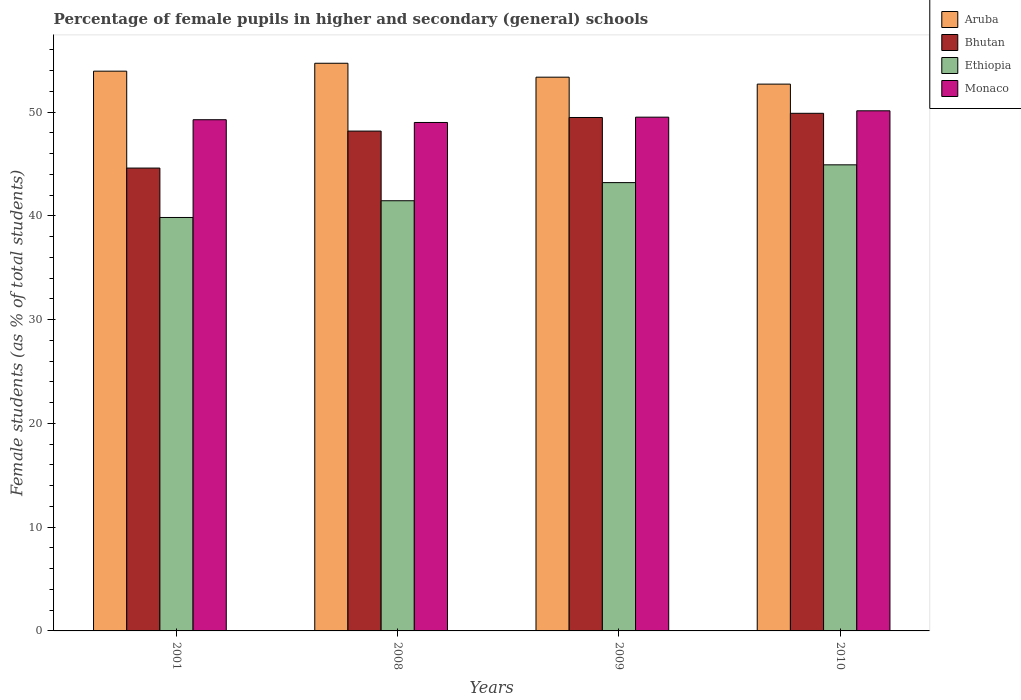How many bars are there on the 3rd tick from the left?
Give a very brief answer. 4. How many bars are there on the 4th tick from the right?
Keep it short and to the point. 4. What is the percentage of female pupils in higher and secondary schools in Monaco in 2010?
Your answer should be very brief. 50.12. Across all years, what is the maximum percentage of female pupils in higher and secondary schools in Aruba?
Your answer should be compact. 54.7. Across all years, what is the minimum percentage of female pupils in higher and secondary schools in Ethiopia?
Give a very brief answer. 39.84. What is the total percentage of female pupils in higher and secondary schools in Bhutan in the graph?
Ensure brevity in your answer.  192.13. What is the difference between the percentage of female pupils in higher and secondary schools in Aruba in 2001 and that in 2009?
Give a very brief answer. 0.58. What is the difference between the percentage of female pupils in higher and secondary schools in Monaco in 2001 and the percentage of female pupils in higher and secondary schools in Aruba in 2009?
Your response must be concise. -4.1. What is the average percentage of female pupils in higher and secondary schools in Ethiopia per year?
Make the answer very short. 42.35. In the year 2008, what is the difference between the percentage of female pupils in higher and secondary schools in Aruba and percentage of female pupils in higher and secondary schools in Monaco?
Provide a short and direct response. 5.71. In how many years, is the percentage of female pupils in higher and secondary schools in Ethiopia greater than 16 %?
Your answer should be very brief. 4. What is the ratio of the percentage of female pupils in higher and secondary schools in Aruba in 2001 to that in 2010?
Make the answer very short. 1.02. Is the percentage of female pupils in higher and secondary schools in Aruba in 2009 less than that in 2010?
Make the answer very short. No. Is the difference between the percentage of female pupils in higher and secondary schools in Aruba in 2001 and 2008 greater than the difference between the percentage of female pupils in higher and secondary schools in Monaco in 2001 and 2008?
Make the answer very short. No. What is the difference between the highest and the second highest percentage of female pupils in higher and secondary schools in Ethiopia?
Offer a very short reply. 1.71. What is the difference between the highest and the lowest percentage of female pupils in higher and secondary schools in Aruba?
Give a very brief answer. 2.01. Is the sum of the percentage of female pupils in higher and secondary schools in Ethiopia in 2001 and 2009 greater than the maximum percentage of female pupils in higher and secondary schools in Aruba across all years?
Your response must be concise. Yes. What does the 2nd bar from the left in 2010 represents?
Offer a very short reply. Bhutan. What does the 1st bar from the right in 2008 represents?
Keep it short and to the point. Monaco. Is it the case that in every year, the sum of the percentage of female pupils in higher and secondary schools in Ethiopia and percentage of female pupils in higher and secondary schools in Bhutan is greater than the percentage of female pupils in higher and secondary schools in Monaco?
Ensure brevity in your answer.  Yes. How many bars are there?
Offer a very short reply. 16. Are all the bars in the graph horizontal?
Your answer should be compact. No. How many years are there in the graph?
Your response must be concise. 4. Does the graph contain any zero values?
Your answer should be compact. No. How many legend labels are there?
Provide a short and direct response. 4. What is the title of the graph?
Provide a succinct answer. Percentage of female pupils in higher and secondary (general) schools. Does "Georgia" appear as one of the legend labels in the graph?
Offer a very short reply. No. What is the label or title of the X-axis?
Give a very brief answer. Years. What is the label or title of the Y-axis?
Ensure brevity in your answer.  Female students (as % of total students). What is the Female students (as % of total students) of Aruba in 2001?
Offer a terse response. 53.94. What is the Female students (as % of total students) in Bhutan in 2001?
Ensure brevity in your answer.  44.6. What is the Female students (as % of total students) of Ethiopia in 2001?
Offer a terse response. 39.84. What is the Female students (as % of total students) in Monaco in 2001?
Keep it short and to the point. 49.26. What is the Female students (as % of total students) of Aruba in 2008?
Provide a short and direct response. 54.7. What is the Female students (as % of total students) in Bhutan in 2008?
Your answer should be very brief. 48.17. What is the Female students (as % of total students) of Ethiopia in 2008?
Your answer should be compact. 41.45. What is the Female students (as % of total students) in Monaco in 2008?
Keep it short and to the point. 49. What is the Female students (as % of total students) of Aruba in 2009?
Provide a short and direct response. 53.36. What is the Female students (as % of total students) of Bhutan in 2009?
Your answer should be very brief. 49.48. What is the Female students (as % of total students) in Ethiopia in 2009?
Your answer should be compact. 43.2. What is the Female students (as % of total students) of Monaco in 2009?
Ensure brevity in your answer.  49.51. What is the Female students (as % of total students) in Aruba in 2010?
Provide a succinct answer. 52.69. What is the Female students (as % of total students) of Bhutan in 2010?
Your answer should be very brief. 49.88. What is the Female students (as % of total students) of Ethiopia in 2010?
Ensure brevity in your answer.  44.92. What is the Female students (as % of total students) in Monaco in 2010?
Your response must be concise. 50.12. Across all years, what is the maximum Female students (as % of total students) in Aruba?
Provide a short and direct response. 54.7. Across all years, what is the maximum Female students (as % of total students) in Bhutan?
Make the answer very short. 49.88. Across all years, what is the maximum Female students (as % of total students) in Ethiopia?
Offer a terse response. 44.92. Across all years, what is the maximum Female students (as % of total students) of Monaco?
Provide a succinct answer. 50.12. Across all years, what is the minimum Female students (as % of total students) of Aruba?
Provide a succinct answer. 52.69. Across all years, what is the minimum Female students (as % of total students) in Bhutan?
Ensure brevity in your answer.  44.6. Across all years, what is the minimum Female students (as % of total students) of Ethiopia?
Offer a very short reply. 39.84. Across all years, what is the minimum Female students (as % of total students) in Monaco?
Your answer should be very brief. 49. What is the total Female students (as % of total students) in Aruba in the graph?
Ensure brevity in your answer.  214.7. What is the total Female students (as % of total students) of Bhutan in the graph?
Offer a very short reply. 192.13. What is the total Female students (as % of total students) in Ethiopia in the graph?
Provide a short and direct response. 169.41. What is the total Female students (as % of total students) in Monaco in the graph?
Provide a succinct answer. 197.89. What is the difference between the Female students (as % of total students) in Aruba in 2001 and that in 2008?
Your response must be concise. -0.76. What is the difference between the Female students (as % of total students) in Bhutan in 2001 and that in 2008?
Ensure brevity in your answer.  -3.56. What is the difference between the Female students (as % of total students) of Ethiopia in 2001 and that in 2008?
Provide a short and direct response. -1.61. What is the difference between the Female students (as % of total students) in Monaco in 2001 and that in 2008?
Offer a terse response. 0.26. What is the difference between the Female students (as % of total students) in Aruba in 2001 and that in 2009?
Offer a terse response. 0.58. What is the difference between the Female students (as % of total students) in Bhutan in 2001 and that in 2009?
Your response must be concise. -4.87. What is the difference between the Female students (as % of total students) in Ethiopia in 2001 and that in 2009?
Offer a terse response. -3.36. What is the difference between the Female students (as % of total students) in Monaco in 2001 and that in 2009?
Provide a succinct answer. -0.25. What is the difference between the Female students (as % of total students) in Aruba in 2001 and that in 2010?
Make the answer very short. 1.25. What is the difference between the Female students (as % of total students) of Bhutan in 2001 and that in 2010?
Your answer should be compact. -5.28. What is the difference between the Female students (as % of total students) of Ethiopia in 2001 and that in 2010?
Your answer should be compact. -5.07. What is the difference between the Female students (as % of total students) in Monaco in 2001 and that in 2010?
Provide a short and direct response. -0.86. What is the difference between the Female students (as % of total students) in Aruba in 2008 and that in 2009?
Provide a succinct answer. 1.34. What is the difference between the Female students (as % of total students) of Bhutan in 2008 and that in 2009?
Give a very brief answer. -1.31. What is the difference between the Female students (as % of total students) of Ethiopia in 2008 and that in 2009?
Your answer should be compact. -1.75. What is the difference between the Female students (as % of total students) in Monaco in 2008 and that in 2009?
Provide a short and direct response. -0.51. What is the difference between the Female students (as % of total students) in Aruba in 2008 and that in 2010?
Your response must be concise. 2.01. What is the difference between the Female students (as % of total students) of Bhutan in 2008 and that in 2010?
Ensure brevity in your answer.  -1.71. What is the difference between the Female students (as % of total students) in Ethiopia in 2008 and that in 2010?
Offer a very short reply. -3.46. What is the difference between the Female students (as % of total students) in Monaco in 2008 and that in 2010?
Keep it short and to the point. -1.12. What is the difference between the Female students (as % of total students) in Aruba in 2009 and that in 2010?
Provide a succinct answer. 0.67. What is the difference between the Female students (as % of total students) in Bhutan in 2009 and that in 2010?
Offer a very short reply. -0.4. What is the difference between the Female students (as % of total students) of Ethiopia in 2009 and that in 2010?
Keep it short and to the point. -1.71. What is the difference between the Female students (as % of total students) in Monaco in 2009 and that in 2010?
Your answer should be compact. -0.61. What is the difference between the Female students (as % of total students) in Aruba in 2001 and the Female students (as % of total students) in Bhutan in 2008?
Ensure brevity in your answer.  5.78. What is the difference between the Female students (as % of total students) of Aruba in 2001 and the Female students (as % of total students) of Ethiopia in 2008?
Your answer should be compact. 12.49. What is the difference between the Female students (as % of total students) in Aruba in 2001 and the Female students (as % of total students) in Monaco in 2008?
Offer a terse response. 4.95. What is the difference between the Female students (as % of total students) in Bhutan in 2001 and the Female students (as % of total students) in Ethiopia in 2008?
Provide a short and direct response. 3.15. What is the difference between the Female students (as % of total students) of Bhutan in 2001 and the Female students (as % of total students) of Monaco in 2008?
Make the answer very short. -4.39. What is the difference between the Female students (as % of total students) in Ethiopia in 2001 and the Female students (as % of total students) in Monaco in 2008?
Your answer should be very brief. -9.16. What is the difference between the Female students (as % of total students) in Aruba in 2001 and the Female students (as % of total students) in Bhutan in 2009?
Provide a short and direct response. 4.47. What is the difference between the Female students (as % of total students) of Aruba in 2001 and the Female students (as % of total students) of Ethiopia in 2009?
Make the answer very short. 10.74. What is the difference between the Female students (as % of total students) of Aruba in 2001 and the Female students (as % of total students) of Monaco in 2009?
Your response must be concise. 4.43. What is the difference between the Female students (as % of total students) in Bhutan in 2001 and the Female students (as % of total students) in Ethiopia in 2009?
Your answer should be very brief. 1.4. What is the difference between the Female students (as % of total students) of Bhutan in 2001 and the Female students (as % of total students) of Monaco in 2009?
Offer a very short reply. -4.91. What is the difference between the Female students (as % of total students) in Ethiopia in 2001 and the Female students (as % of total students) in Monaco in 2009?
Your answer should be very brief. -9.67. What is the difference between the Female students (as % of total students) of Aruba in 2001 and the Female students (as % of total students) of Bhutan in 2010?
Keep it short and to the point. 4.06. What is the difference between the Female students (as % of total students) in Aruba in 2001 and the Female students (as % of total students) in Ethiopia in 2010?
Make the answer very short. 9.03. What is the difference between the Female students (as % of total students) of Aruba in 2001 and the Female students (as % of total students) of Monaco in 2010?
Ensure brevity in your answer.  3.82. What is the difference between the Female students (as % of total students) of Bhutan in 2001 and the Female students (as % of total students) of Ethiopia in 2010?
Your answer should be very brief. -0.31. What is the difference between the Female students (as % of total students) in Bhutan in 2001 and the Female students (as % of total students) in Monaco in 2010?
Offer a terse response. -5.52. What is the difference between the Female students (as % of total students) in Ethiopia in 2001 and the Female students (as % of total students) in Monaco in 2010?
Provide a succinct answer. -10.28. What is the difference between the Female students (as % of total students) of Aruba in 2008 and the Female students (as % of total students) of Bhutan in 2009?
Provide a short and direct response. 5.23. What is the difference between the Female students (as % of total students) of Aruba in 2008 and the Female students (as % of total students) of Ethiopia in 2009?
Give a very brief answer. 11.5. What is the difference between the Female students (as % of total students) in Aruba in 2008 and the Female students (as % of total students) in Monaco in 2009?
Your response must be concise. 5.2. What is the difference between the Female students (as % of total students) of Bhutan in 2008 and the Female students (as % of total students) of Ethiopia in 2009?
Your answer should be very brief. 4.97. What is the difference between the Female students (as % of total students) of Bhutan in 2008 and the Female students (as % of total students) of Monaco in 2009?
Your response must be concise. -1.34. What is the difference between the Female students (as % of total students) in Ethiopia in 2008 and the Female students (as % of total students) in Monaco in 2009?
Your answer should be compact. -8.05. What is the difference between the Female students (as % of total students) in Aruba in 2008 and the Female students (as % of total students) in Bhutan in 2010?
Ensure brevity in your answer.  4.82. What is the difference between the Female students (as % of total students) in Aruba in 2008 and the Female students (as % of total students) in Ethiopia in 2010?
Offer a terse response. 9.79. What is the difference between the Female students (as % of total students) in Aruba in 2008 and the Female students (as % of total students) in Monaco in 2010?
Your response must be concise. 4.58. What is the difference between the Female students (as % of total students) in Bhutan in 2008 and the Female students (as % of total students) in Ethiopia in 2010?
Offer a terse response. 3.25. What is the difference between the Female students (as % of total students) in Bhutan in 2008 and the Female students (as % of total students) in Monaco in 2010?
Your answer should be compact. -1.96. What is the difference between the Female students (as % of total students) in Ethiopia in 2008 and the Female students (as % of total students) in Monaco in 2010?
Provide a succinct answer. -8.67. What is the difference between the Female students (as % of total students) in Aruba in 2009 and the Female students (as % of total students) in Bhutan in 2010?
Your answer should be compact. 3.48. What is the difference between the Female students (as % of total students) of Aruba in 2009 and the Female students (as % of total students) of Ethiopia in 2010?
Offer a terse response. 8.45. What is the difference between the Female students (as % of total students) of Aruba in 2009 and the Female students (as % of total students) of Monaco in 2010?
Make the answer very short. 3.24. What is the difference between the Female students (as % of total students) in Bhutan in 2009 and the Female students (as % of total students) in Ethiopia in 2010?
Provide a short and direct response. 4.56. What is the difference between the Female students (as % of total students) of Bhutan in 2009 and the Female students (as % of total students) of Monaco in 2010?
Your answer should be compact. -0.64. What is the difference between the Female students (as % of total students) of Ethiopia in 2009 and the Female students (as % of total students) of Monaco in 2010?
Your answer should be very brief. -6.92. What is the average Female students (as % of total students) of Aruba per year?
Provide a succinct answer. 53.68. What is the average Female students (as % of total students) of Bhutan per year?
Ensure brevity in your answer.  48.03. What is the average Female students (as % of total students) of Ethiopia per year?
Offer a very short reply. 42.35. What is the average Female students (as % of total students) of Monaco per year?
Provide a succinct answer. 49.47. In the year 2001, what is the difference between the Female students (as % of total students) in Aruba and Female students (as % of total students) in Bhutan?
Give a very brief answer. 9.34. In the year 2001, what is the difference between the Female students (as % of total students) of Aruba and Female students (as % of total students) of Ethiopia?
Offer a very short reply. 14.1. In the year 2001, what is the difference between the Female students (as % of total students) of Aruba and Female students (as % of total students) of Monaco?
Your answer should be very brief. 4.68. In the year 2001, what is the difference between the Female students (as % of total students) of Bhutan and Female students (as % of total students) of Ethiopia?
Your answer should be very brief. 4.76. In the year 2001, what is the difference between the Female students (as % of total students) in Bhutan and Female students (as % of total students) in Monaco?
Keep it short and to the point. -4.66. In the year 2001, what is the difference between the Female students (as % of total students) in Ethiopia and Female students (as % of total students) in Monaco?
Give a very brief answer. -9.42. In the year 2008, what is the difference between the Female students (as % of total students) of Aruba and Female students (as % of total students) of Bhutan?
Offer a terse response. 6.54. In the year 2008, what is the difference between the Female students (as % of total students) in Aruba and Female students (as % of total students) in Ethiopia?
Offer a terse response. 13.25. In the year 2008, what is the difference between the Female students (as % of total students) of Aruba and Female students (as % of total students) of Monaco?
Offer a terse response. 5.71. In the year 2008, what is the difference between the Female students (as % of total students) in Bhutan and Female students (as % of total students) in Ethiopia?
Ensure brevity in your answer.  6.71. In the year 2008, what is the difference between the Female students (as % of total students) in Bhutan and Female students (as % of total students) in Monaco?
Give a very brief answer. -0.83. In the year 2008, what is the difference between the Female students (as % of total students) of Ethiopia and Female students (as % of total students) of Monaco?
Offer a very short reply. -7.54. In the year 2009, what is the difference between the Female students (as % of total students) of Aruba and Female students (as % of total students) of Bhutan?
Your response must be concise. 3.88. In the year 2009, what is the difference between the Female students (as % of total students) of Aruba and Female students (as % of total students) of Ethiopia?
Offer a terse response. 10.16. In the year 2009, what is the difference between the Female students (as % of total students) of Aruba and Female students (as % of total students) of Monaco?
Your answer should be compact. 3.85. In the year 2009, what is the difference between the Female students (as % of total students) in Bhutan and Female students (as % of total students) in Ethiopia?
Offer a very short reply. 6.28. In the year 2009, what is the difference between the Female students (as % of total students) of Bhutan and Female students (as % of total students) of Monaco?
Your answer should be very brief. -0.03. In the year 2009, what is the difference between the Female students (as % of total students) of Ethiopia and Female students (as % of total students) of Monaco?
Your answer should be compact. -6.31. In the year 2010, what is the difference between the Female students (as % of total students) in Aruba and Female students (as % of total students) in Bhutan?
Keep it short and to the point. 2.81. In the year 2010, what is the difference between the Female students (as % of total students) in Aruba and Female students (as % of total students) in Ethiopia?
Your answer should be very brief. 7.78. In the year 2010, what is the difference between the Female students (as % of total students) of Aruba and Female students (as % of total students) of Monaco?
Make the answer very short. 2.57. In the year 2010, what is the difference between the Female students (as % of total students) of Bhutan and Female students (as % of total students) of Ethiopia?
Give a very brief answer. 4.96. In the year 2010, what is the difference between the Female students (as % of total students) in Bhutan and Female students (as % of total students) in Monaco?
Offer a very short reply. -0.24. In the year 2010, what is the difference between the Female students (as % of total students) in Ethiopia and Female students (as % of total students) in Monaco?
Make the answer very short. -5.21. What is the ratio of the Female students (as % of total students) of Aruba in 2001 to that in 2008?
Give a very brief answer. 0.99. What is the ratio of the Female students (as % of total students) of Bhutan in 2001 to that in 2008?
Your answer should be compact. 0.93. What is the ratio of the Female students (as % of total students) of Ethiopia in 2001 to that in 2008?
Make the answer very short. 0.96. What is the ratio of the Female students (as % of total students) in Monaco in 2001 to that in 2008?
Give a very brief answer. 1.01. What is the ratio of the Female students (as % of total students) of Aruba in 2001 to that in 2009?
Provide a short and direct response. 1.01. What is the ratio of the Female students (as % of total students) in Bhutan in 2001 to that in 2009?
Provide a succinct answer. 0.9. What is the ratio of the Female students (as % of total students) in Ethiopia in 2001 to that in 2009?
Give a very brief answer. 0.92. What is the ratio of the Female students (as % of total students) of Aruba in 2001 to that in 2010?
Your answer should be compact. 1.02. What is the ratio of the Female students (as % of total students) in Bhutan in 2001 to that in 2010?
Your answer should be compact. 0.89. What is the ratio of the Female students (as % of total students) of Ethiopia in 2001 to that in 2010?
Offer a very short reply. 0.89. What is the ratio of the Female students (as % of total students) of Monaco in 2001 to that in 2010?
Provide a succinct answer. 0.98. What is the ratio of the Female students (as % of total students) in Aruba in 2008 to that in 2009?
Your answer should be very brief. 1.03. What is the ratio of the Female students (as % of total students) of Bhutan in 2008 to that in 2009?
Your answer should be compact. 0.97. What is the ratio of the Female students (as % of total students) in Ethiopia in 2008 to that in 2009?
Offer a terse response. 0.96. What is the ratio of the Female students (as % of total students) in Aruba in 2008 to that in 2010?
Keep it short and to the point. 1.04. What is the ratio of the Female students (as % of total students) in Bhutan in 2008 to that in 2010?
Keep it short and to the point. 0.97. What is the ratio of the Female students (as % of total students) in Ethiopia in 2008 to that in 2010?
Give a very brief answer. 0.92. What is the ratio of the Female students (as % of total students) in Monaco in 2008 to that in 2010?
Offer a very short reply. 0.98. What is the ratio of the Female students (as % of total students) of Aruba in 2009 to that in 2010?
Offer a terse response. 1.01. What is the ratio of the Female students (as % of total students) of Bhutan in 2009 to that in 2010?
Offer a very short reply. 0.99. What is the ratio of the Female students (as % of total students) in Ethiopia in 2009 to that in 2010?
Make the answer very short. 0.96. What is the difference between the highest and the second highest Female students (as % of total students) of Aruba?
Your response must be concise. 0.76. What is the difference between the highest and the second highest Female students (as % of total students) in Bhutan?
Offer a very short reply. 0.4. What is the difference between the highest and the second highest Female students (as % of total students) in Ethiopia?
Your answer should be very brief. 1.71. What is the difference between the highest and the second highest Female students (as % of total students) in Monaco?
Offer a very short reply. 0.61. What is the difference between the highest and the lowest Female students (as % of total students) in Aruba?
Your answer should be compact. 2.01. What is the difference between the highest and the lowest Female students (as % of total students) of Bhutan?
Give a very brief answer. 5.28. What is the difference between the highest and the lowest Female students (as % of total students) of Ethiopia?
Provide a short and direct response. 5.07. What is the difference between the highest and the lowest Female students (as % of total students) in Monaco?
Offer a terse response. 1.12. 